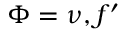<formula> <loc_0><loc_0><loc_500><loc_500>\Phi = \nu , f ^ { \prime }</formula> 